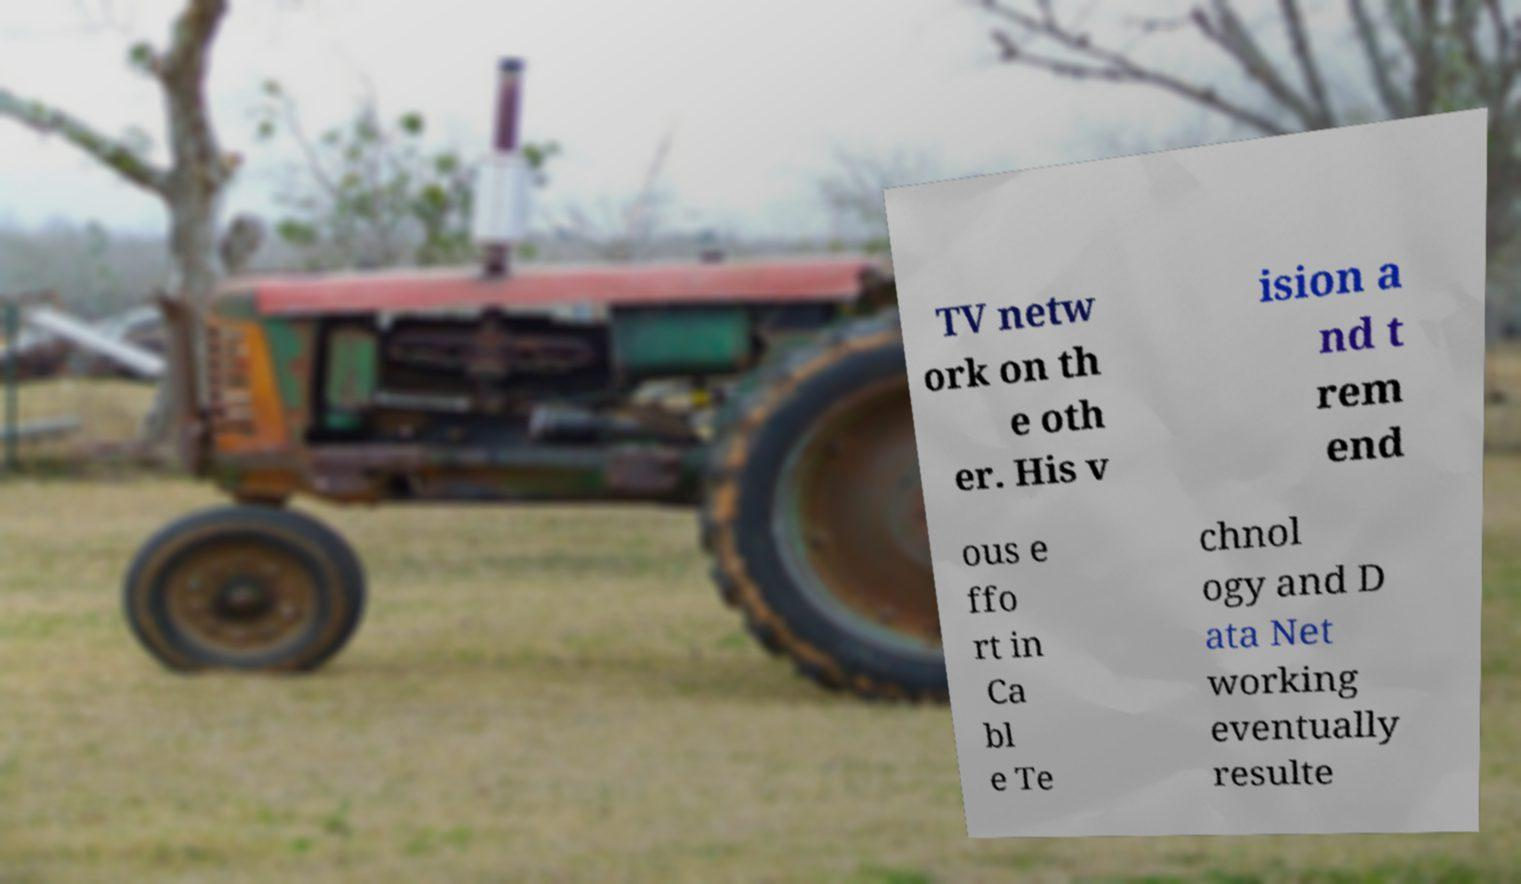Could you assist in decoding the text presented in this image and type it out clearly? TV netw ork on th e oth er. His v ision a nd t rem end ous e ffo rt in Ca bl e Te chnol ogy and D ata Net working eventually resulte 